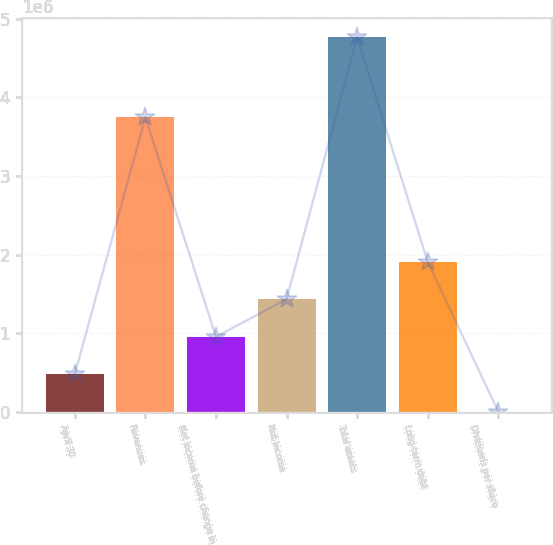<chart> <loc_0><loc_0><loc_500><loc_500><bar_chart><fcel>April 30<fcel>Revenues<fcel>Net income before change in<fcel>Net income<fcel>Total assets<fcel>Long-term debt<fcel>Dividends per share<nl><fcel>476731<fcel>3.74646e+06<fcel>953462<fcel>1.43019e+06<fcel>4.76731e+06<fcel>1.90692e+06<fcel>0.7<nl></chart> 